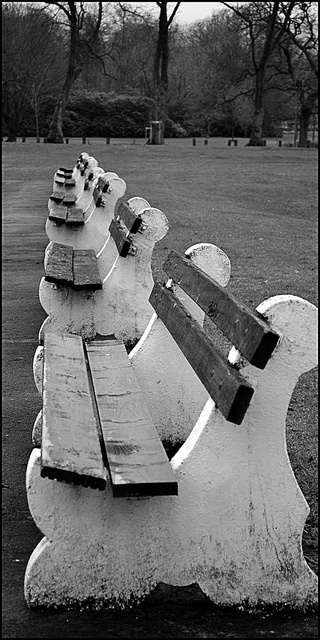Describe the objects in this image and their specific colors. I can see bench in black, darkgray, gray, and lightgray tones, bench in black, darkgray, gray, and lightgray tones, bench in black, darkgray, gray, and lightgray tones, bench in black, darkgray, gray, and lightgray tones, and bench in black, darkgray, gray, and lightgray tones in this image. 